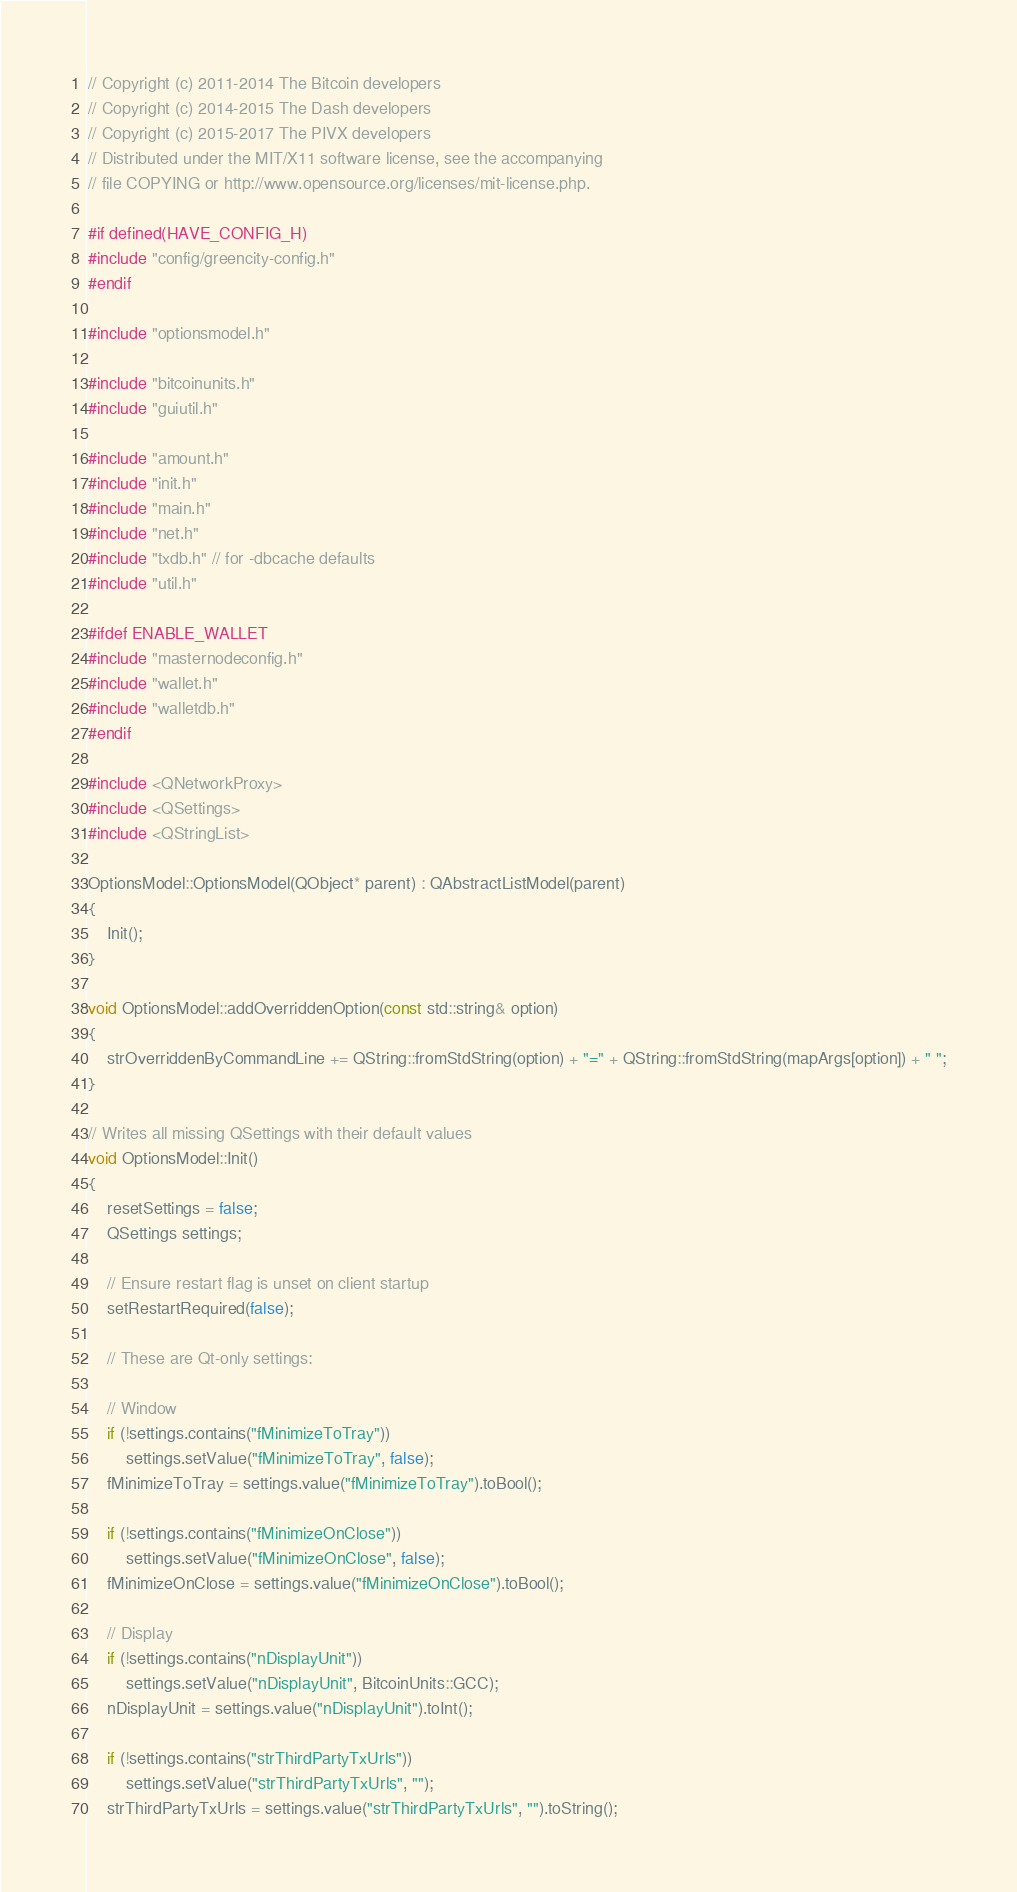Convert code to text. <code><loc_0><loc_0><loc_500><loc_500><_C++_>// Copyright (c) 2011-2014 The Bitcoin developers
// Copyright (c) 2014-2015 The Dash developers
// Copyright (c) 2015-2017 The PIVX developers
// Distributed under the MIT/X11 software license, see the accompanying
// file COPYING or http://www.opensource.org/licenses/mit-license.php.

#if defined(HAVE_CONFIG_H)
#include "config/greencity-config.h"
#endif

#include "optionsmodel.h"

#include "bitcoinunits.h"
#include "guiutil.h"

#include "amount.h"
#include "init.h"
#include "main.h"
#include "net.h"
#include "txdb.h" // for -dbcache defaults
#include "util.h"

#ifdef ENABLE_WALLET
#include "masternodeconfig.h"
#include "wallet.h"
#include "walletdb.h"
#endif

#include <QNetworkProxy>
#include <QSettings>
#include <QStringList>

OptionsModel::OptionsModel(QObject* parent) : QAbstractListModel(parent)
{
    Init();
}

void OptionsModel::addOverriddenOption(const std::string& option)
{
    strOverriddenByCommandLine += QString::fromStdString(option) + "=" + QString::fromStdString(mapArgs[option]) + " ";
}

// Writes all missing QSettings with their default values
void OptionsModel::Init()
{
    resetSettings = false;
    QSettings settings;

    // Ensure restart flag is unset on client startup
    setRestartRequired(false);

    // These are Qt-only settings:

    // Window
    if (!settings.contains("fMinimizeToTray"))
        settings.setValue("fMinimizeToTray", false);
    fMinimizeToTray = settings.value("fMinimizeToTray").toBool();

    if (!settings.contains("fMinimizeOnClose"))
        settings.setValue("fMinimizeOnClose", false);
    fMinimizeOnClose = settings.value("fMinimizeOnClose").toBool();

    // Display
    if (!settings.contains("nDisplayUnit"))
        settings.setValue("nDisplayUnit", BitcoinUnits::GCC);
    nDisplayUnit = settings.value("nDisplayUnit").toInt();

    if (!settings.contains("strThirdPartyTxUrls"))
        settings.setValue("strThirdPartyTxUrls", "");
    strThirdPartyTxUrls = settings.value("strThirdPartyTxUrls", "").toString();
</code> 